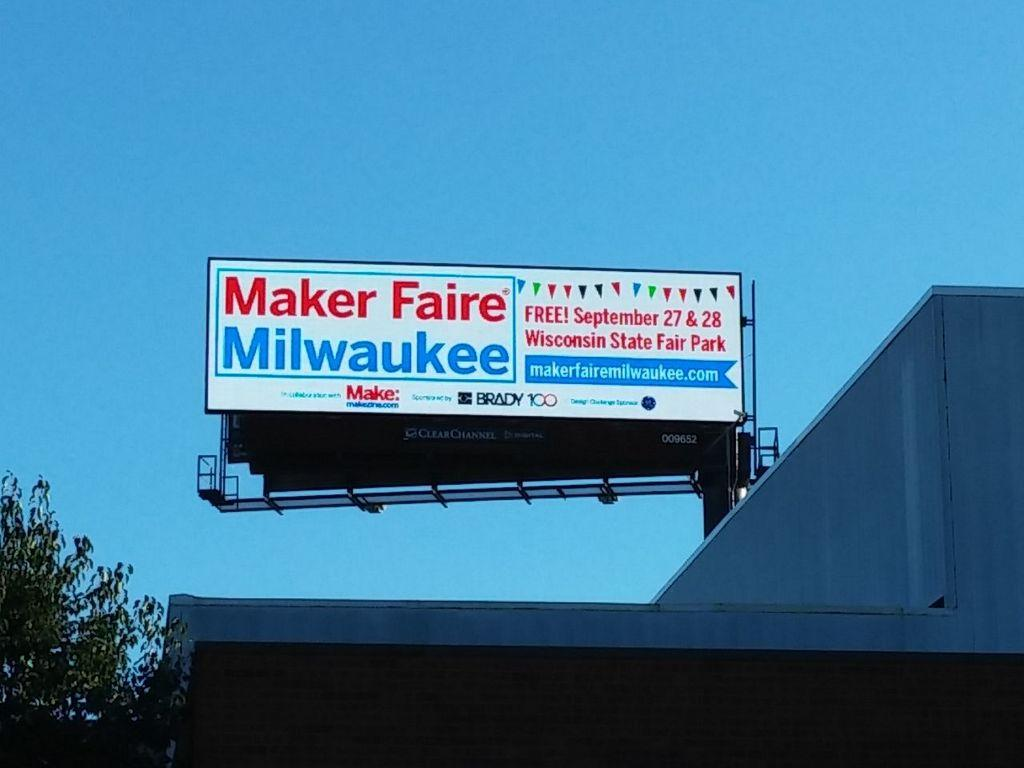<image>
Offer a succinct explanation of the picture presented. A billboard advertising the Maker Faire in Milwaukee. 